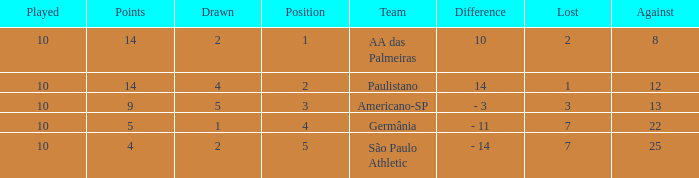What team has an against more than 8, lost of 7, and the position is 5? São Paulo Athletic. 